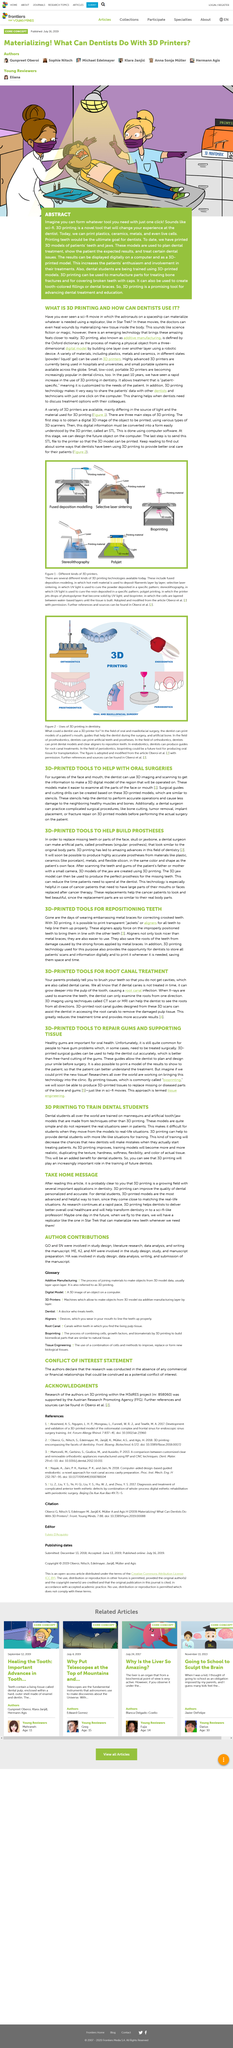Highlight a few significant elements in this photo. 3D printed tools, used in conjunction with 3D imaging and scanning, offer a highly accurate and customizable solution for oral surgeries, allowing dentists to create precise digital models of the affected region for safe and effective treatment. Bioprinting is a process by which living cells are printed onto a substrate to create tissues or organs for medical or scientific purposes. This technique has the potential to revolutionize the field of regenerative medicine by enabling the creation of customized tissues and organs for transplantation or research. Stereolithography is a 3D printing technology that uses UV light to cure resin deposited in a specific pattern, resulting in the creation of three-dimensional objects. 3D printing, also known as additive manufacturing, is a process of creating a physical object from a digital file by layering materials, such as plastic, metal, or ceramic. It is imperative that healthy gums are prioritized for optimal oral health. 